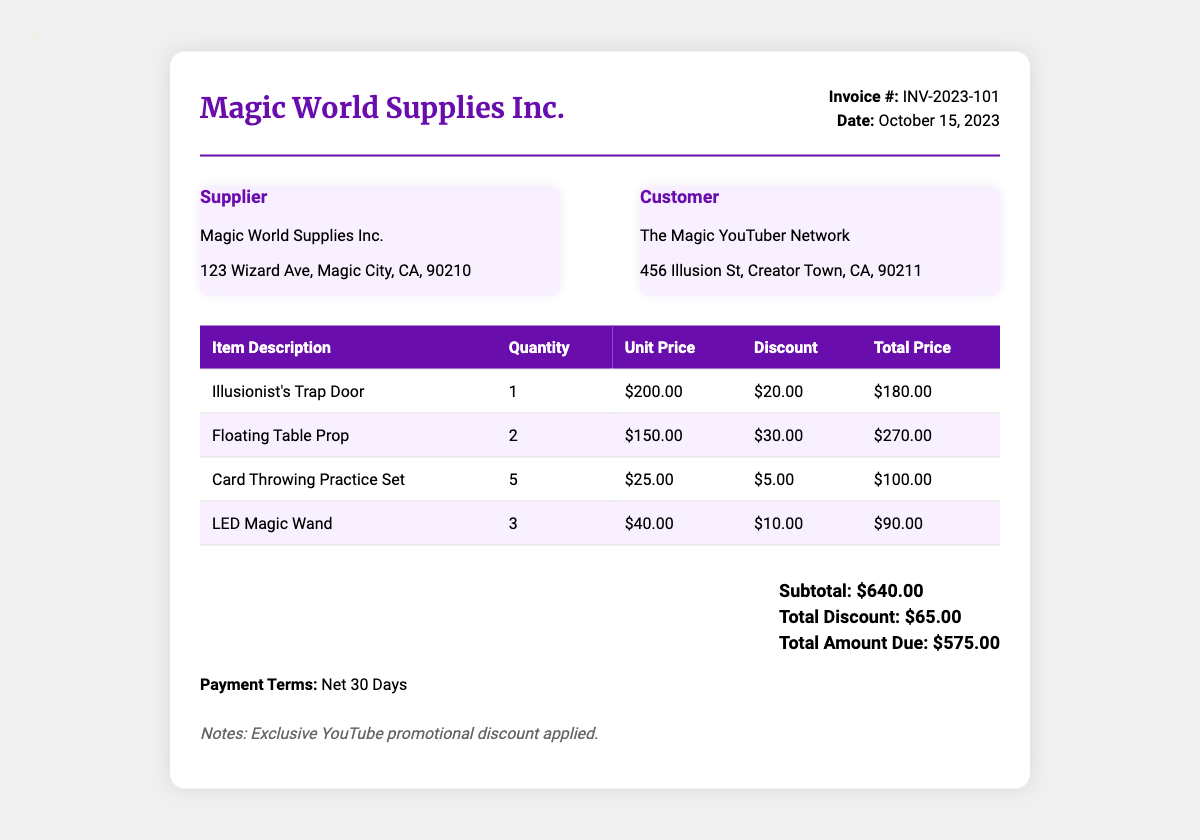What is the invoice number? The invoice number is detailed in the header section of the document.
Answer: INV-2023-101 When was the invoice issued? The date of the invoice is provided in the header section of the document.
Answer: October 15, 2023 Who is the supplier? The supplier's name and address are listed in the address section.
Answer: Magic World Supplies Inc What item has the highest unit price? Analyzing the prices in the item table will reveal the item with the highest unit price.
Answer: Illusionist's Trap Door What is the total amount due? The total amount due is at the bottom of the total section of the invoice.
Answer: $575.00 What is the total discount applied? The total discount is specified in the total section towards the end of the document.
Answer: $65.00 How many LED Magic Wands were sold? The quantity sold for each item is listed in the itemized table.
Answer: 3 What is the subtotal before discounts? The subtotal before discounts is noted in the total section of the document.
Answer: $640.00 What is the payment term specified? The payment terms are described at the end of the document.
Answer: Net 30 Days 